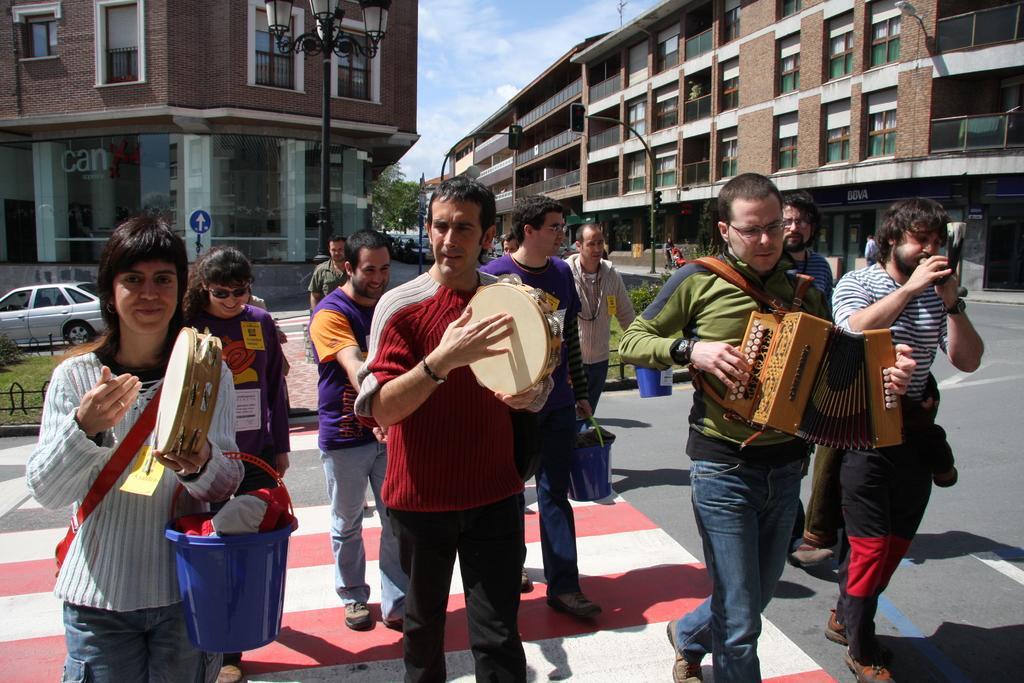Can you describe this image briefly? In this image I can see a road, on the road there are group of people visible and some of them holding musical instruments and some of them holding buckets , there are buildings visible on the road , in front of building there are poles, lights and vehicles visible and in the middle there is the sky and tree visible. 